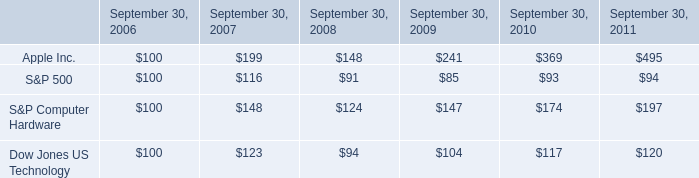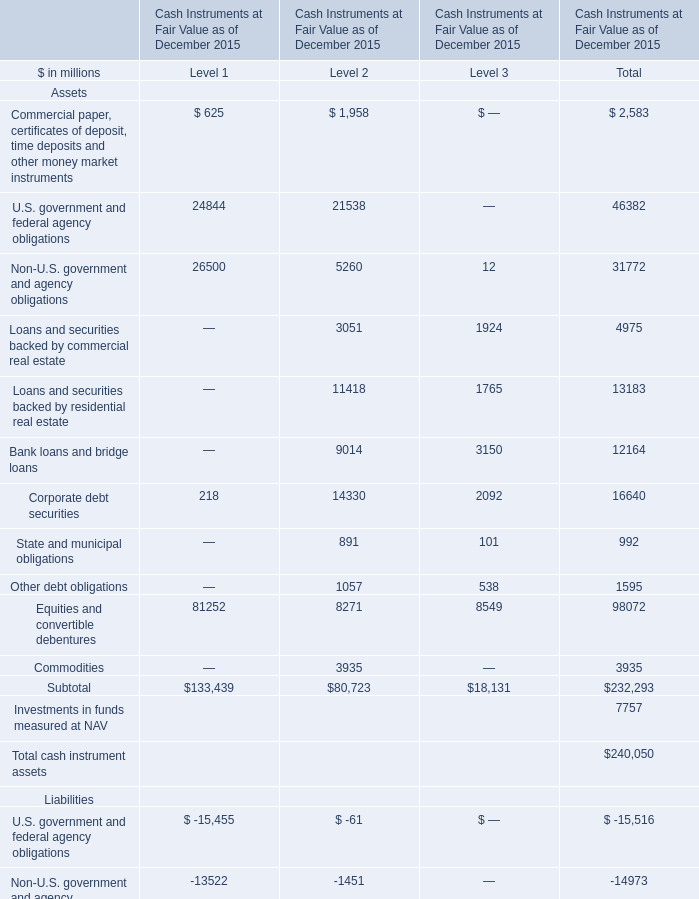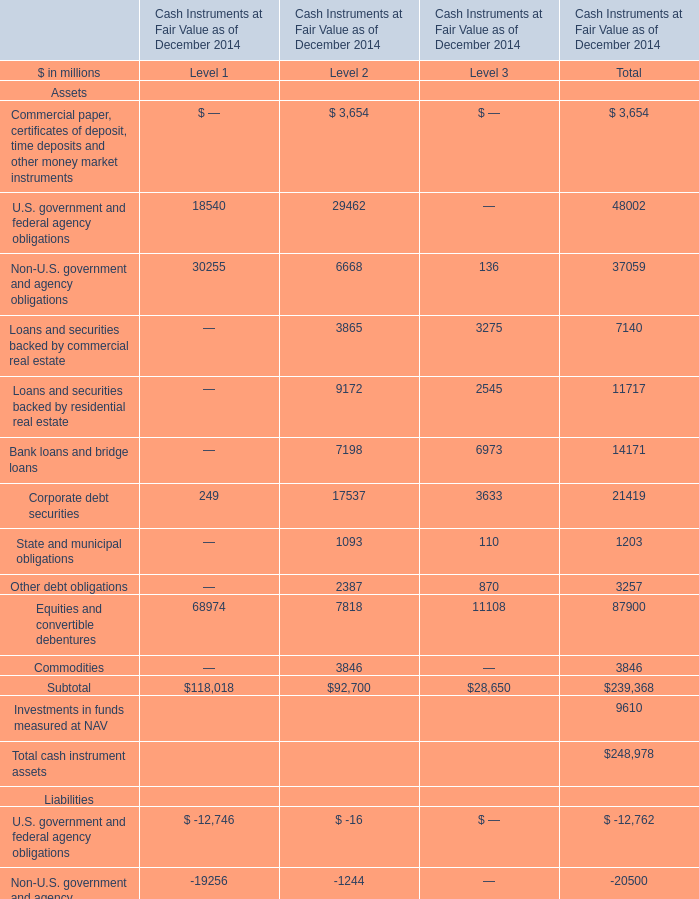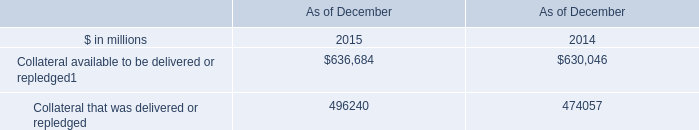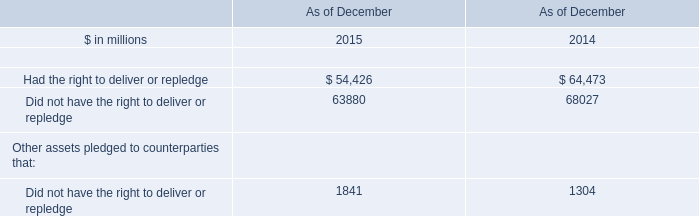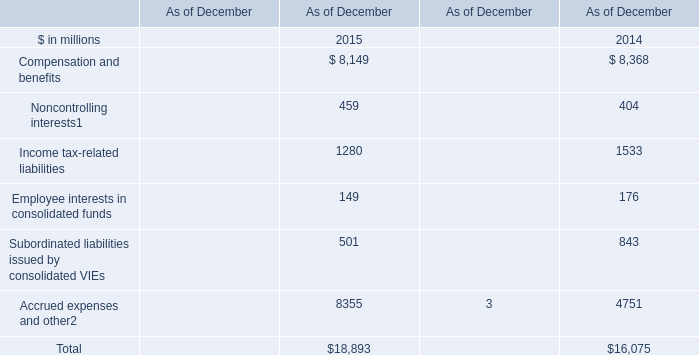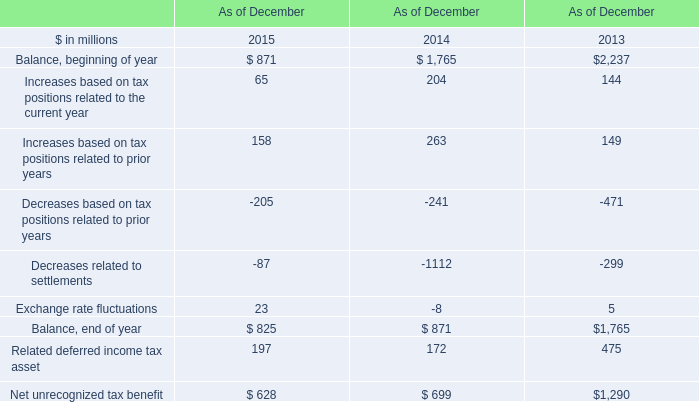what was the cumulative percentage return for the four years ended september 30 , 2010 for apple inc.? 
Computations: ((369 - 100) / 100)
Answer: 2.69. 